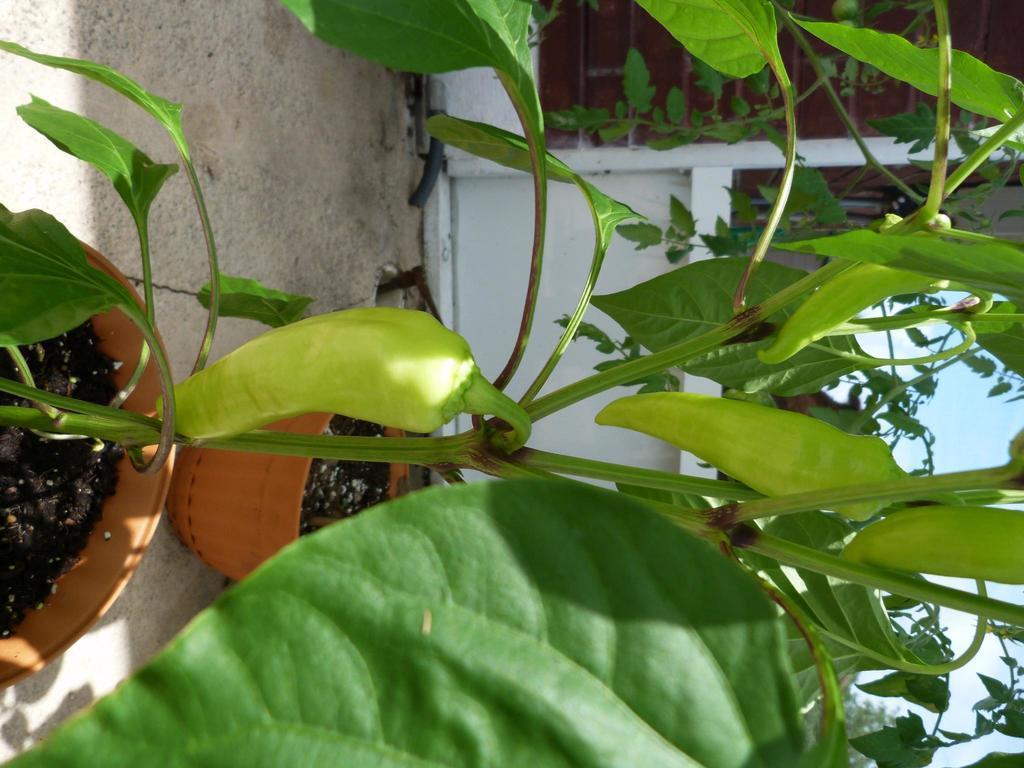How would you summarize this image in a sentence or two? In this image there are two plant pots on the floor. In the background there is a wall. At the top there is the sky. This image is in vertical position. To the plants there are chilies. 